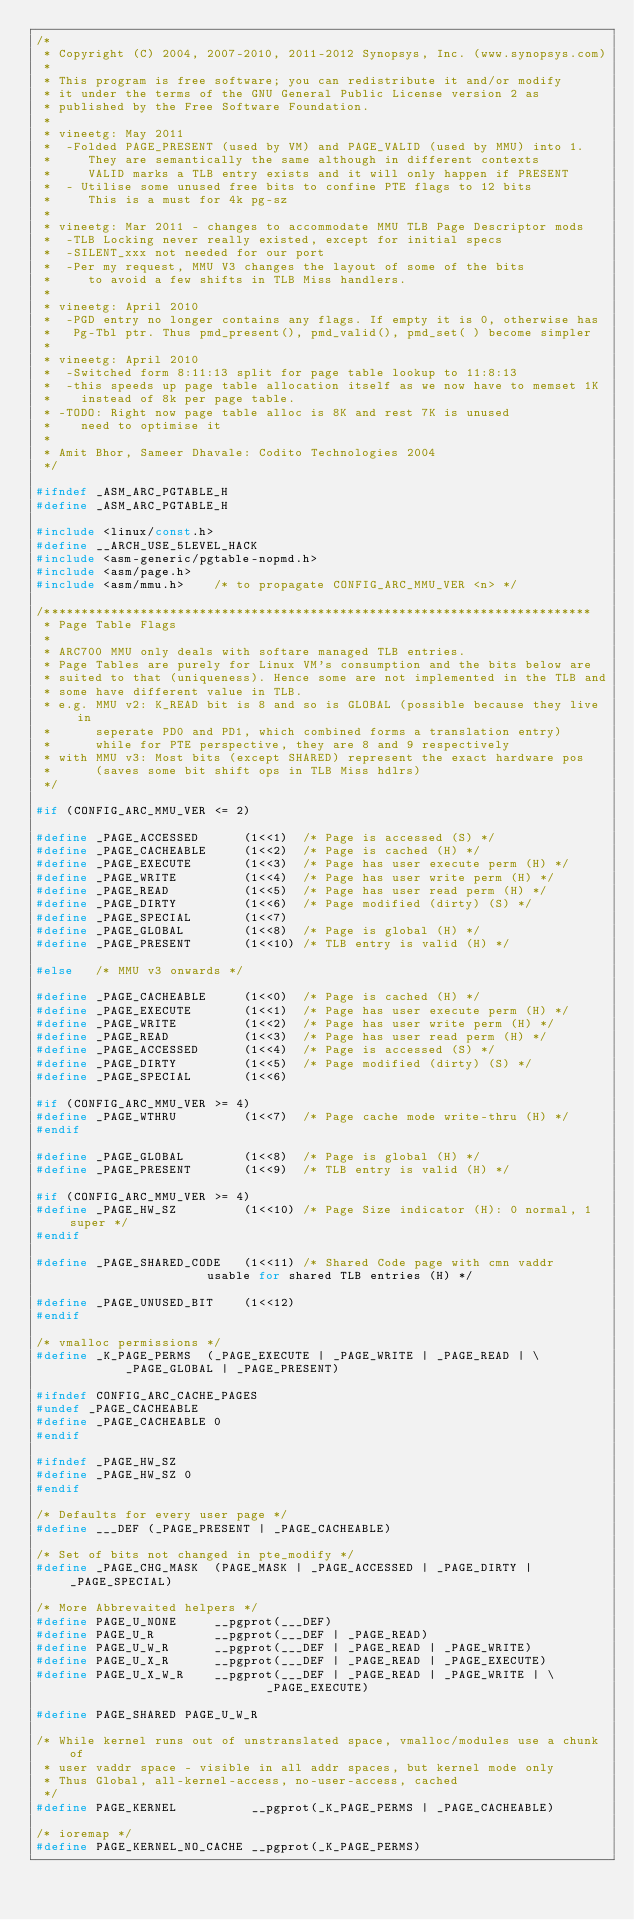Convert code to text. <code><loc_0><loc_0><loc_500><loc_500><_C_>/*
 * Copyright (C) 2004, 2007-2010, 2011-2012 Synopsys, Inc. (www.synopsys.com)
 *
 * This program is free software; you can redistribute it and/or modify
 * it under the terms of the GNU General Public License version 2 as
 * published by the Free Software Foundation.
 *
 * vineetg: May 2011
 *  -Folded PAGE_PRESENT (used by VM) and PAGE_VALID (used by MMU) into 1.
 *     They are semantically the same although in different contexts
 *     VALID marks a TLB entry exists and it will only happen if PRESENT
 *  - Utilise some unused free bits to confine PTE flags to 12 bits
 *     This is a must for 4k pg-sz
 *
 * vineetg: Mar 2011 - changes to accommodate MMU TLB Page Descriptor mods
 *  -TLB Locking never really existed, except for initial specs
 *  -SILENT_xxx not needed for our port
 *  -Per my request, MMU V3 changes the layout of some of the bits
 *     to avoid a few shifts in TLB Miss handlers.
 *
 * vineetg: April 2010
 *  -PGD entry no longer contains any flags. If empty it is 0, otherwise has
 *   Pg-Tbl ptr. Thus pmd_present(), pmd_valid(), pmd_set( ) become simpler
 *
 * vineetg: April 2010
 *  -Switched form 8:11:13 split for page table lookup to 11:8:13
 *  -this speeds up page table allocation itself as we now have to memset 1K
 *    instead of 8k per page table.
 * -TODO: Right now page table alloc is 8K and rest 7K is unused
 *    need to optimise it
 *
 * Amit Bhor, Sameer Dhavale: Codito Technologies 2004
 */

#ifndef _ASM_ARC_PGTABLE_H
#define _ASM_ARC_PGTABLE_H

#include <linux/const.h>
#define __ARCH_USE_5LEVEL_HACK
#include <asm-generic/pgtable-nopmd.h>
#include <asm/page.h>
#include <asm/mmu.h>	/* to propagate CONFIG_ARC_MMU_VER <n> */

/**************************************************************************
 * Page Table Flags
 *
 * ARC700 MMU only deals with softare managed TLB entries.
 * Page Tables are purely for Linux VM's consumption and the bits below are
 * suited to that (uniqueness). Hence some are not implemented in the TLB and
 * some have different value in TLB.
 * e.g. MMU v2: K_READ bit is 8 and so is GLOBAL (possible because they live in
 *      seperate PD0 and PD1, which combined forms a translation entry)
 *      while for PTE perspective, they are 8 and 9 respectively
 * with MMU v3: Most bits (except SHARED) represent the exact hardware pos
 *      (saves some bit shift ops in TLB Miss hdlrs)
 */

#if (CONFIG_ARC_MMU_VER <= 2)

#define _PAGE_ACCESSED      (1<<1)	/* Page is accessed (S) */
#define _PAGE_CACHEABLE     (1<<2)	/* Page is cached (H) */
#define _PAGE_EXECUTE       (1<<3)	/* Page has user execute perm (H) */
#define _PAGE_WRITE         (1<<4)	/* Page has user write perm (H) */
#define _PAGE_READ          (1<<5)	/* Page has user read perm (H) */
#define _PAGE_DIRTY         (1<<6)	/* Page modified (dirty) (S) */
#define _PAGE_SPECIAL       (1<<7)
#define _PAGE_GLOBAL        (1<<8)	/* Page is global (H) */
#define _PAGE_PRESENT       (1<<10)	/* TLB entry is valid (H) */

#else	/* MMU v3 onwards */

#define _PAGE_CACHEABLE     (1<<0)	/* Page is cached (H) */
#define _PAGE_EXECUTE       (1<<1)	/* Page has user execute perm (H) */
#define _PAGE_WRITE         (1<<2)	/* Page has user write perm (H) */
#define _PAGE_READ          (1<<3)	/* Page has user read perm (H) */
#define _PAGE_ACCESSED      (1<<4)	/* Page is accessed (S) */
#define _PAGE_DIRTY         (1<<5)	/* Page modified (dirty) (S) */
#define _PAGE_SPECIAL       (1<<6)

#if (CONFIG_ARC_MMU_VER >= 4)
#define _PAGE_WTHRU         (1<<7)	/* Page cache mode write-thru (H) */
#endif

#define _PAGE_GLOBAL        (1<<8)	/* Page is global (H) */
#define _PAGE_PRESENT       (1<<9)	/* TLB entry is valid (H) */

#if (CONFIG_ARC_MMU_VER >= 4)
#define _PAGE_HW_SZ         (1<<10)	/* Page Size indicator (H): 0 normal, 1 super */
#endif

#define _PAGE_SHARED_CODE   (1<<11)	/* Shared Code page with cmn vaddr
					   usable for shared TLB entries (H) */

#define _PAGE_UNUSED_BIT    (1<<12)
#endif

/* vmalloc permissions */
#define _K_PAGE_PERMS  (_PAGE_EXECUTE | _PAGE_WRITE | _PAGE_READ | \
			_PAGE_GLOBAL | _PAGE_PRESENT)

#ifndef CONFIG_ARC_CACHE_PAGES
#undef _PAGE_CACHEABLE
#define _PAGE_CACHEABLE 0
#endif

#ifndef _PAGE_HW_SZ
#define _PAGE_HW_SZ	0
#endif

/* Defaults for every user page */
#define ___DEF (_PAGE_PRESENT | _PAGE_CACHEABLE)

/* Set of bits not changed in pte_modify */
#define _PAGE_CHG_MASK	(PAGE_MASK | _PAGE_ACCESSED | _PAGE_DIRTY | _PAGE_SPECIAL)

/* More Abbrevaited helpers */
#define PAGE_U_NONE     __pgprot(___DEF)
#define PAGE_U_R        __pgprot(___DEF | _PAGE_READ)
#define PAGE_U_W_R      __pgprot(___DEF | _PAGE_READ | _PAGE_WRITE)
#define PAGE_U_X_R      __pgprot(___DEF | _PAGE_READ | _PAGE_EXECUTE)
#define PAGE_U_X_W_R    __pgprot(___DEF | _PAGE_READ | _PAGE_WRITE | \
						       _PAGE_EXECUTE)

#define PAGE_SHARED	PAGE_U_W_R

/* While kernel runs out of unstranslated space, vmalloc/modules use a chunk of
 * user vaddr space - visible in all addr spaces, but kernel mode only
 * Thus Global, all-kernel-access, no-user-access, cached
 */
#define PAGE_KERNEL          __pgprot(_K_PAGE_PERMS | _PAGE_CACHEABLE)

/* ioremap */
#define PAGE_KERNEL_NO_CACHE __pgprot(_K_PAGE_PERMS)
</code> 